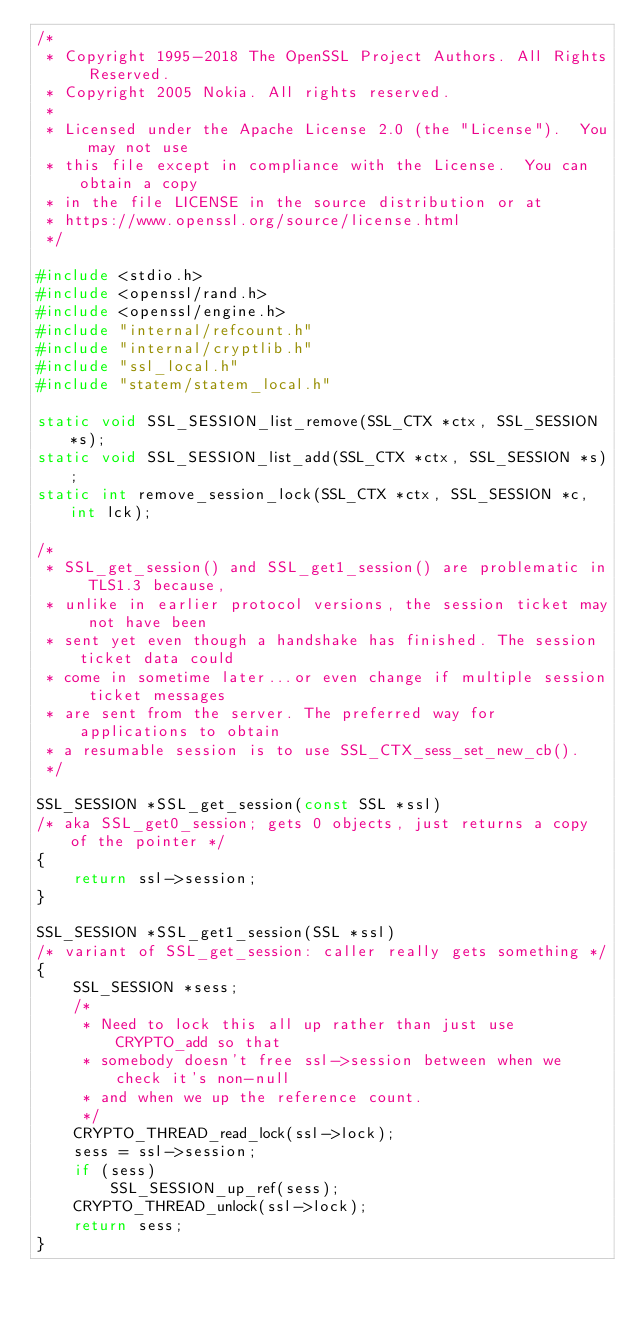<code> <loc_0><loc_0><loc_500><loc_500><_C_>/*
 * Copyright 1995-2018 The OpenSSL Project Authors. All Rights Reserved.
 * Copyright 2005 Nokia. All rights reserved.
 *
 * Licensed under the Apache License 2.0 (the "License").  You may not use
 * this file except in compliance with the License.  You can obtain a copy
 * in the file LICENSE in the source distribution or at
 * https://www.openssl.org/source/license.html
 */

#include <stdio.h>
#include <openssl/rand.h>
#include <openssl/engine.h>
#include "internal/refcount.h"
#include "internal/cryptlib.h"
#include "ssl_local.h"
#include "statem/statem_local.h"

static void SSL_SESSION_list_remove(SSL_CTX *ctx, SSL_SESSION *s);
static void SSL_SESSION_list_add(SSL_CTX *ctx, SSL_SESSION *s);
static int remove_session_lock(SSL_CTX *ctx, SSL_SESSION *c, int lck);

/*
 * SSL_get_session() and SSL_get1_session() are problematic in TLS1.3 because,
 * unlike in earlier protocol versions, the session ticket may not have been
 * sent yet even though a handshake has finished. The session ticket data could
 * come in sometime later...or even change if multiple session ticket messages
 * are sent from the server. The preferred way for applications to obtain
 * a resumable session is to use SSL_CTX_sess_set_new_cb().
 */

SSL_SESSION *SSL_get_session(const SSL *ssl)
/* aka SSL_get0_session; gets 0 objects, just returns a copy of the pointer */
{
    return ssl->session;
}

SSL_SESSION *SSL_get1_session(SSL *ssl)
/* variant of SSL_get_session: caller really gets something */
{
    SSL_SESSION *sess;
    /*
     * Need to lock this all up rather than just use CRYPTO_add so that
     * somebody doesn't free ssl->session between when we check it's non-null
     * and when we up the reference count.
     */
    CRYPTO_THREAD_read_lock(ssl->lock);
    sess = ssl->session;
    if (sess)
        SSL_SESSION_up_ref(sess);
    CRYPTO_THREAD_unlock(ssl->lock);
    return sess;
}
</code> 